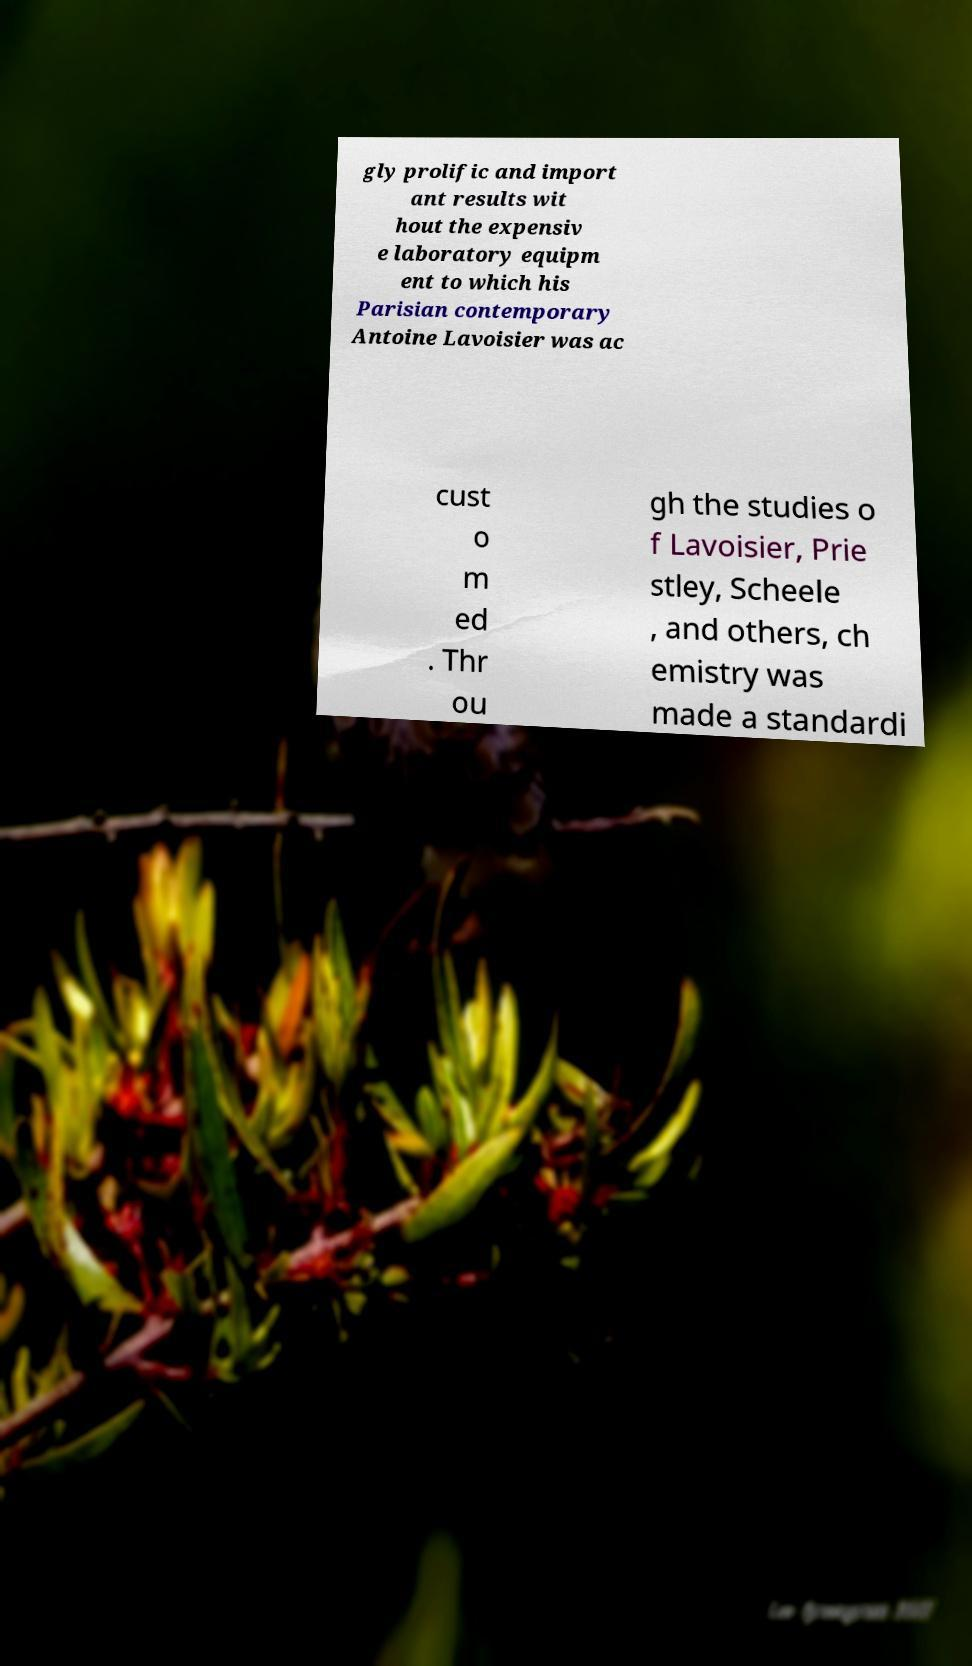Please read and relay the text visible in this image. What does it say? gly prolific and import ant results wit hout the expensiv e laboratory equipm ent to which his Parisian contemporary Antoine Lavoisier was ac cust o m ed . Thr ou gh the studies o f Lavoisier, Prie stley, Scheele , and others, ch emistry was made a standardi 